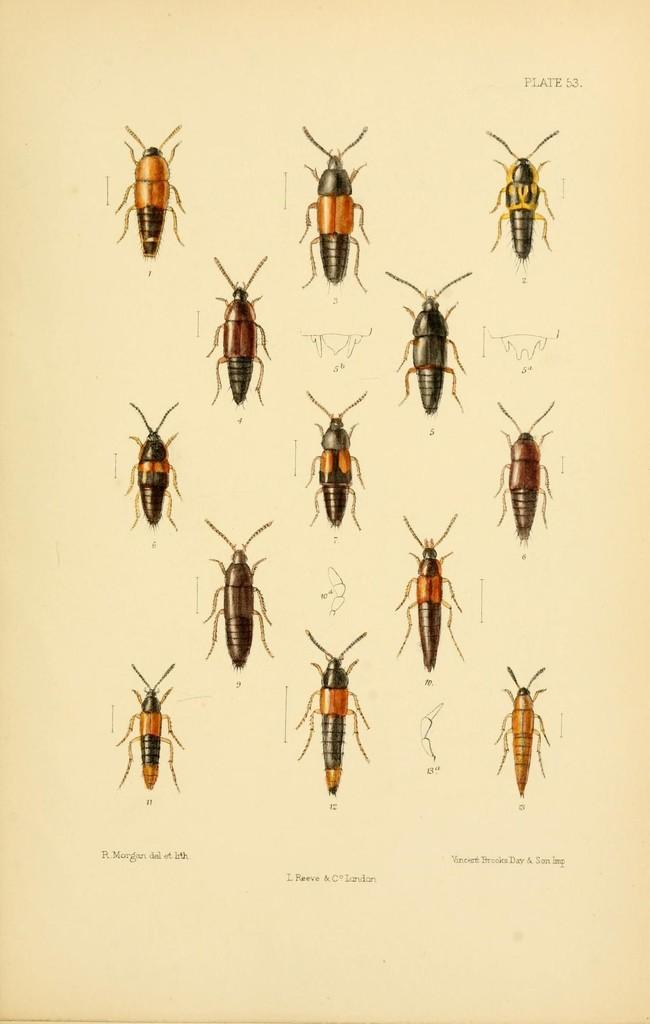What is the main subject of the poster in the image? The poster contains images of insects. What else can be found on the poster besides the insect images? The poster contains text. Can you tell me how many zebras are depicted on the poster? There are no zebras depicted on the poster; it features images of insects and text. 